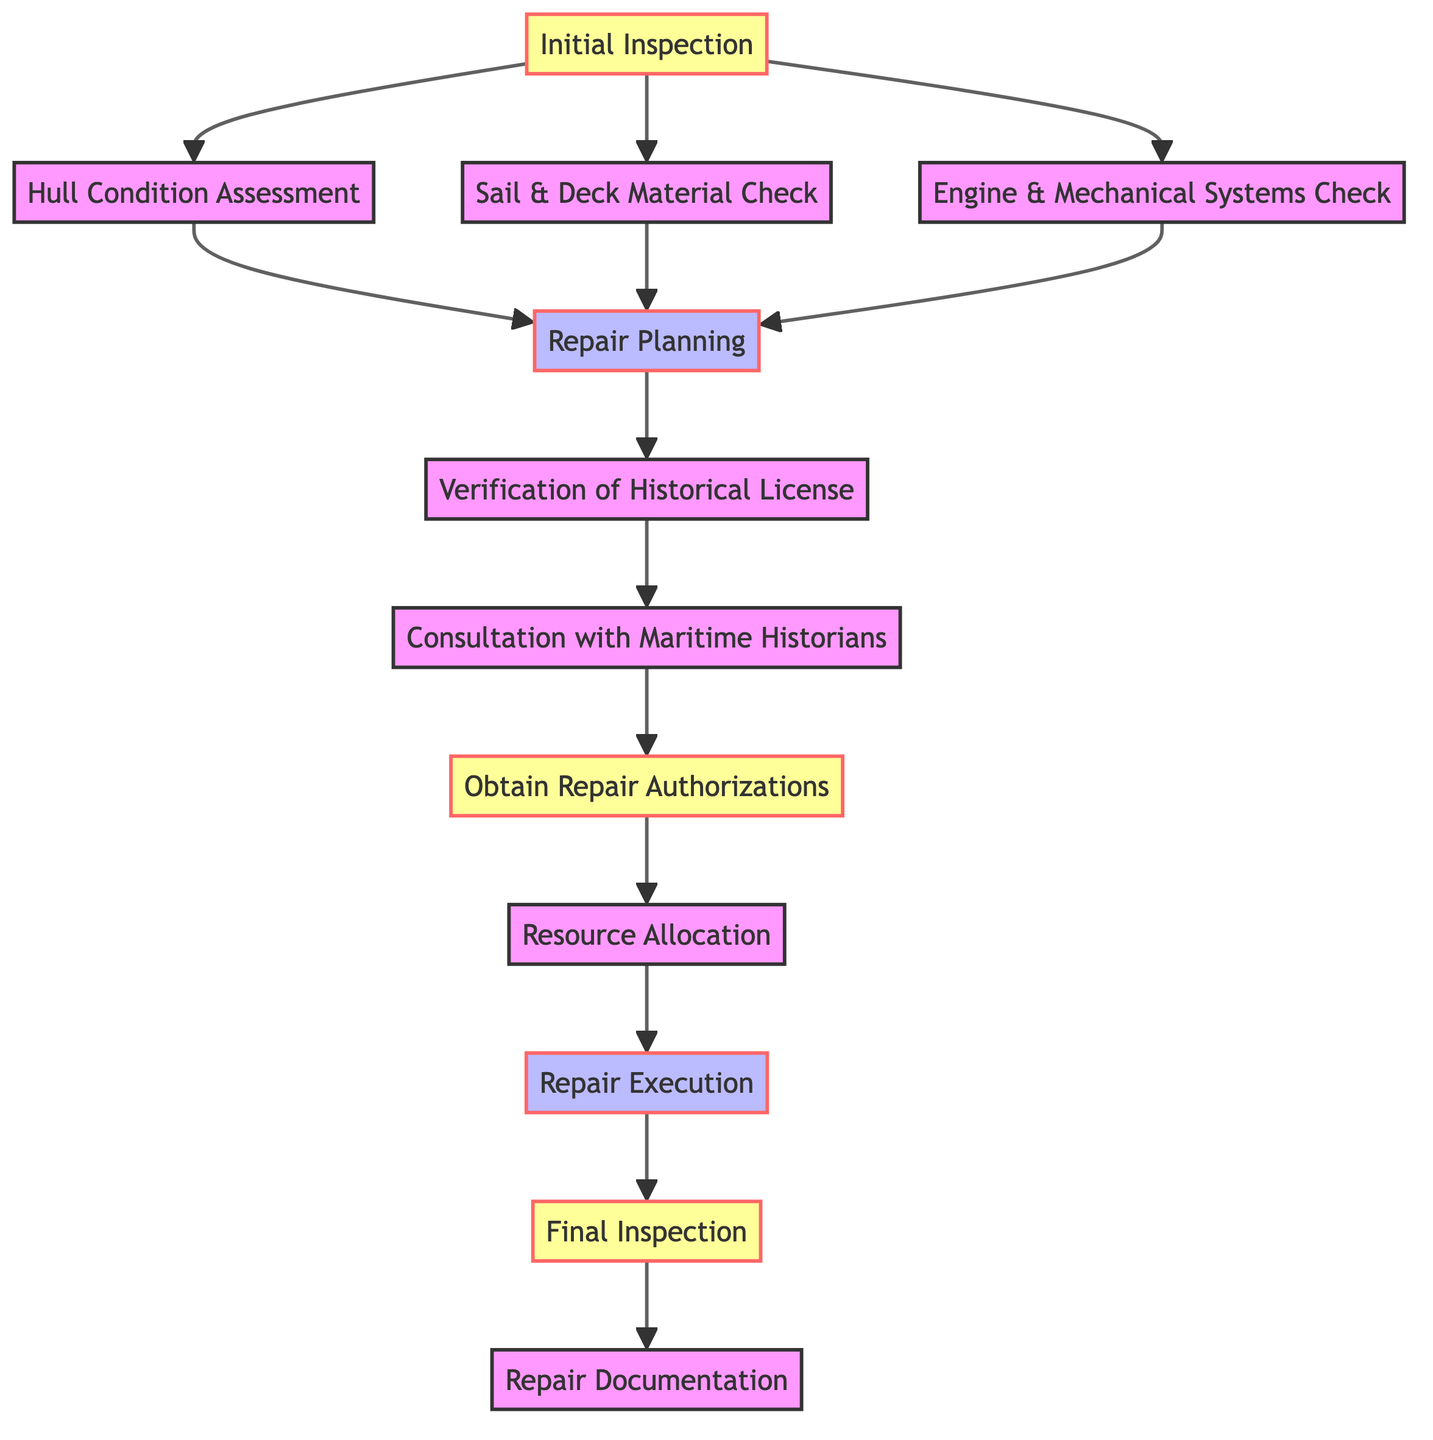What is the starting point of the maintenance workflow? The diagram starts with the "Initial Inspection" node, which is the first step in the workflow.
Answer: Initial Inspection How many nodes are in the maintenance workflow diagram? By counting all listed nodes, there are a total of 12 distinct nodes representing different stages in the maintenance process.
Answer: 12 What is the relationship between "Repair Planning" and "License Verification"? The "Repair Planning" leads to "License Verification," indicating that planning repairs is a prerequisite for verifying licenses.
Answer: Repair Planning → License Verification Which node comes after "Execution"? After "Execution," the next step in the workflow is the "Final Inspection," which ensures all repairs were completed satisfactorily.
Answer: Final Inspection What is the final step in the maintenance workflow? The last step documented in the workflow is "Repair Documentation," which involves recording all repairs made to the historical naval ship.
Answer: Repair Documentation How many processes are involved in the workflow? The processes highlighted in the diagram include "Repair Planning," "Execution," and "Documentation," totaling three processes.
Answer: 3 What step follows "Specialist Consultation"? Following "Specialist Consultation," the workflow moves to "Obtain Repair Authorizations," indicating that authorization is required after consultation with historians.
Answer: Obtain Repair Authorizations What is the node before "Resource Allocation"? The workflow shows that "Obtain Repair Authorizations" directly precedes "Resource Allocation," making it an essential step before allocating resources.
Answer: Obtain Repair Authorizations Which check happens last among the initial inspections? Among the checks performed after the initial inspection, the final one is "Engine & Mechanical Systems Check," as it is required before moving forward in the workflow.
Answer: Engine & Mechanical Systems Check 